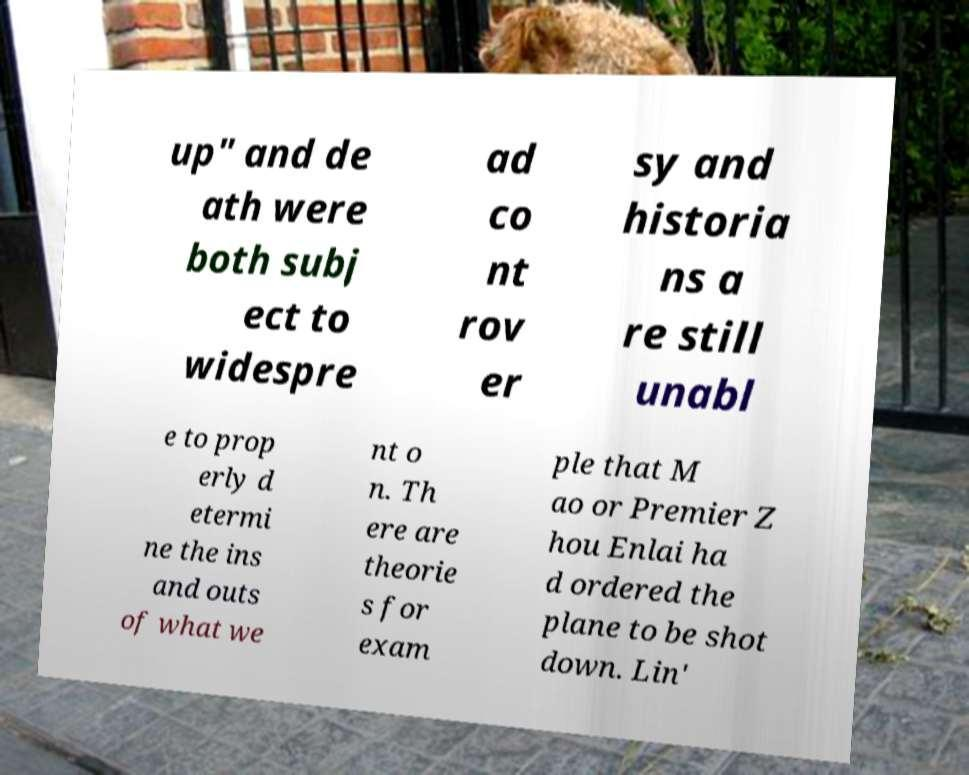What messages or text are displayed in this image? I need them in a readable, typed format. up" and de ath were both subj ect to widespre ad co nt rov er sy and historia ns a re still unabl e to prop erly d etermi ne the ins and outs of what we nt o n. Th ere are theorie s for exam ple that M ao or Premier Z hou Enlai ha d ordered the plane to be shot down. Lin' 